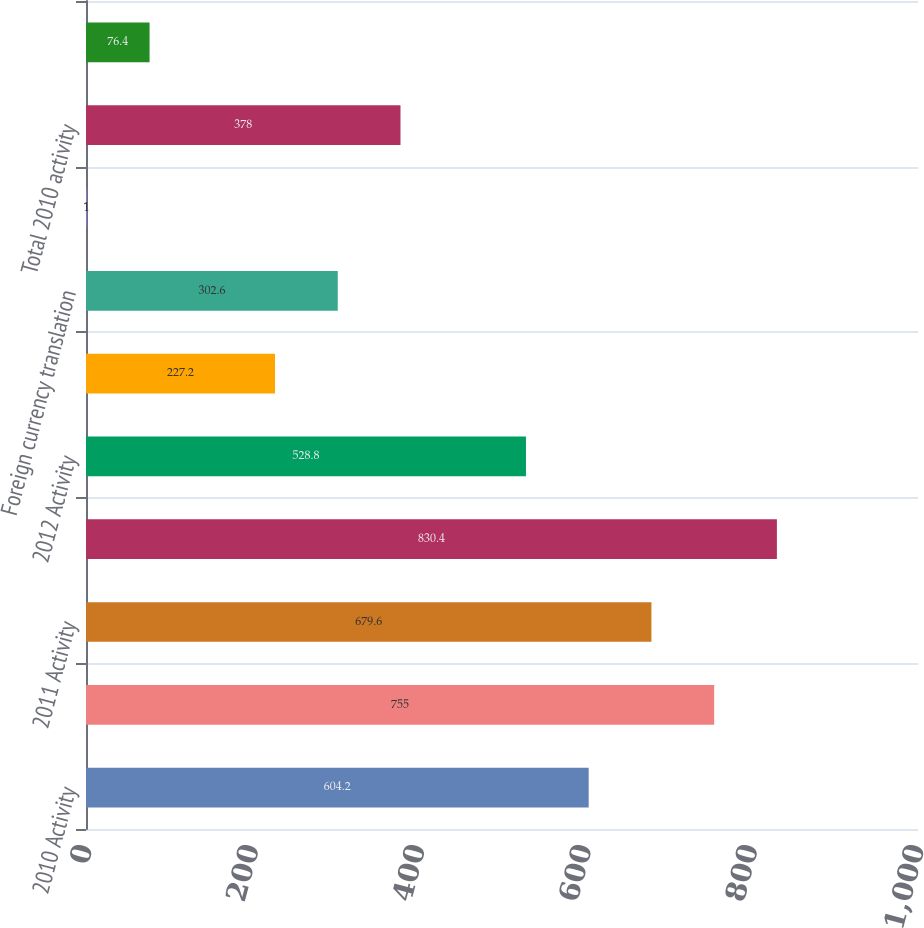Convert chart. <chart><loc_0><loc_0><loc_500><loc_500><bar_chart><fcel>2010 Activity<fcel>Balance at December 31 2010<fcel>2011 Activity<fcel>Balance at December 31 2011<fcel>2012 Activity<fcel>Balance at December 31 2009<fcel>Foreign currency translation<fcel>SBA I/O strip valuation<fcel>Total 2010 activity<fcel>Total 2011 activity<nl><fcel>604.2<fcel>755<fcel>679.6<fcel>830.4<fcel>528.8<fcel>227.2<fcel>302.6<fcel>1<fcel>378<fcel>76.4<nl></chart> 